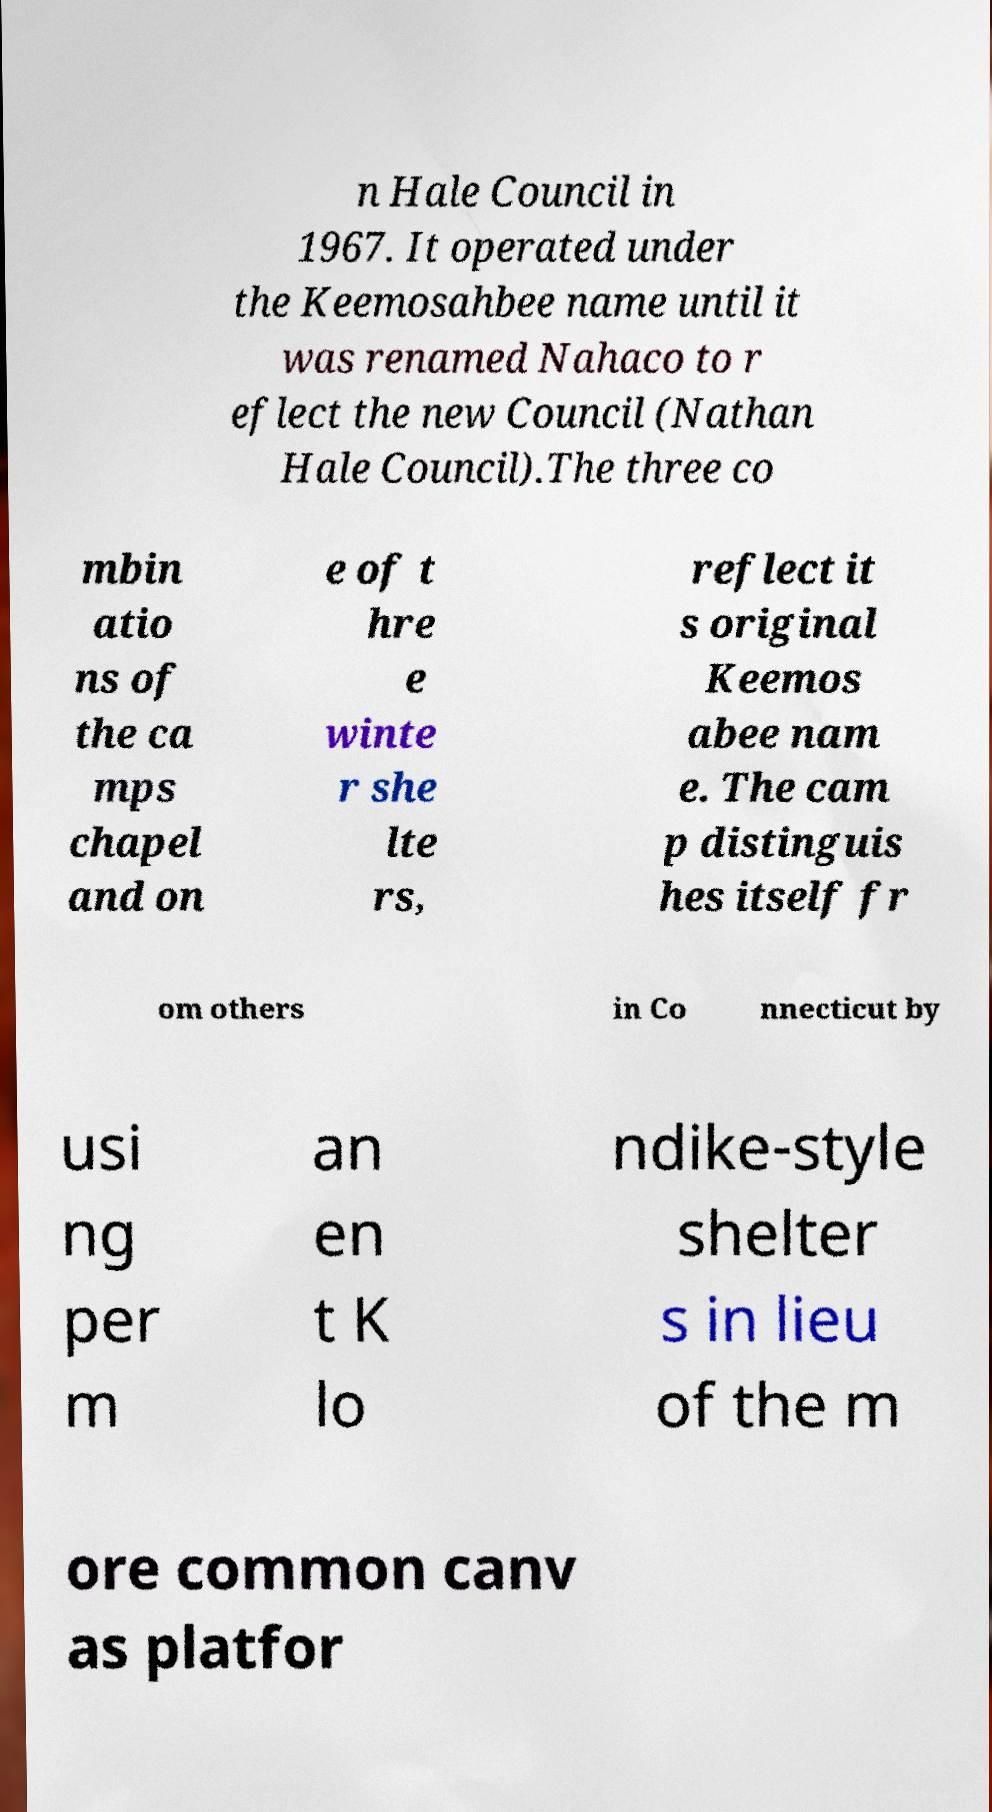There's text embedded in this image that I need extracted. Can you transcribe it verbatim? n Hale Council in 1967. It operated under the Keemosahbee name until it was renamed Nahaco to r eflect the new Council (Nathan Hale Council).The three co mbin atio ns of the ca mps chapel and on e of t hre e winte r she lte rs, reflect it s original Keemos abee nam e. The cam p distinguis hes itself fr om others in Co nnecticut by usi ng per m an en t K lo ndike-style shelter s in lieu of the m ore common canv as platfor 